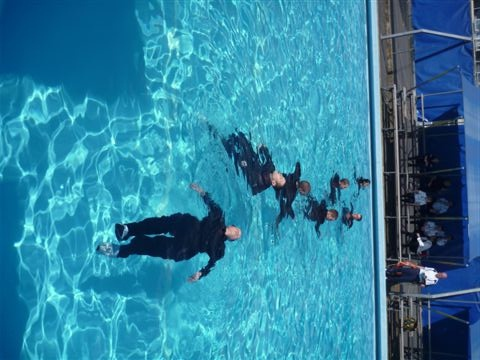Describe the objects in this image and their specific colors. I can see people in blue, black, teal, and navy tones, bench in blue, black, gray, and darkgray tones, people in blue, navy, black, and teal tones, people in blue, navy, black, and gray tones, and people in blue, black, navy, lavender, and gray tones in this image. 